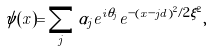<formula> <loc_0><loc_0><loc_500><loc_500>\psi ( x ) = \sum _ { j } \alpha _ { j } e ^ { i \theta _ { j } } e ^ { - ( x - j d ) ^ { 2 } / 2 \xi ^ { 2 } } ,</formula> 